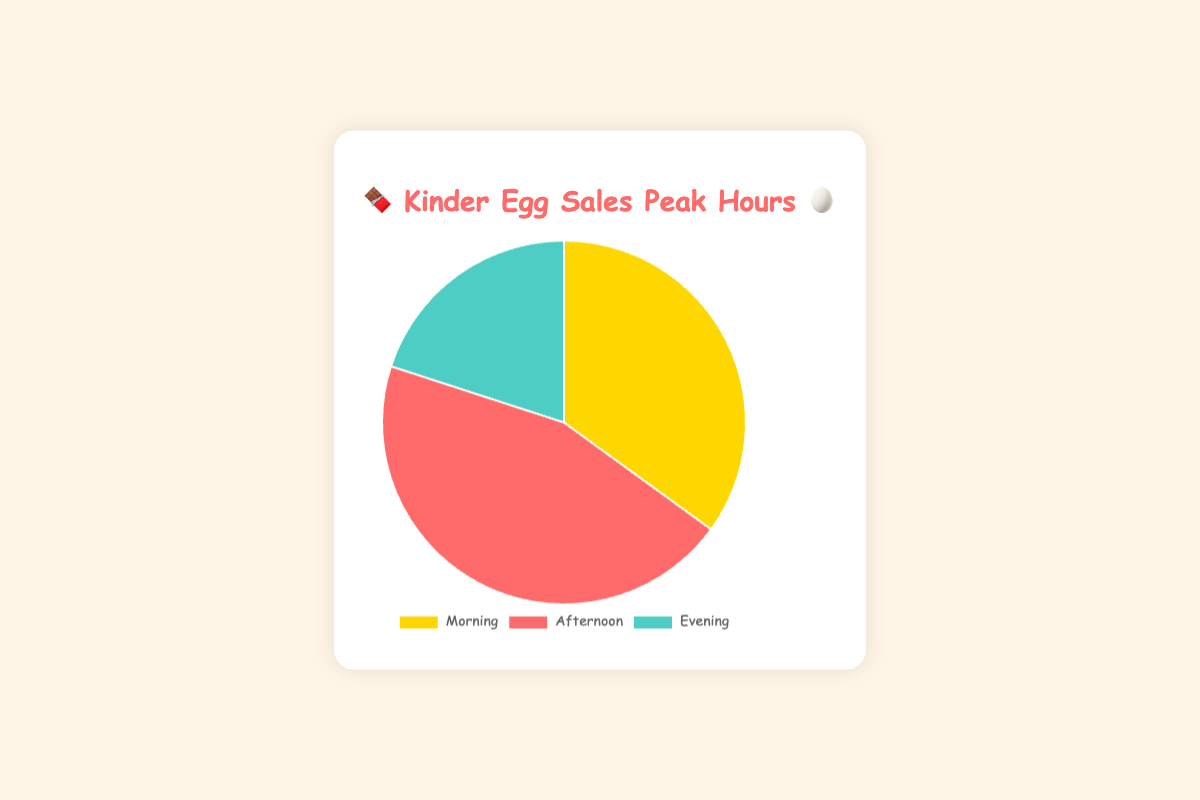what's the peak sales time for Kinder Eggs? The chart shows the sales data divided into three periods: Morning, Afternoon, and Evening. The highest sales percentage is for the Afternoon.
Answer: Afternoon How much higher are the sales in the Afternoon compared to the Evening? The Afternoon sales are 45%, and the Evening sales are 20%. The difference can be calculated as 45% - 20% = 25%.
Answer: 25% What percentage of the sales happen in the Morning? The chart shows that the Morning sales account for 35% of the total sales.
Answer: 35% Which period has the lowest sales percentage? By observing the chart, the period with the smallest segment is the Evening, which has a sales percentage of 20%.
Answer: Evening What are the combined sales percentages for Morning and Evening? Adding the sales percentages for Morning and Evening gives us 35% + 20% = 55%.
Answer: 55% How do Evening sales compare to the Morning sales? The Evening sales (20%) are lower than the Morning sales (35%).
Answer: lower What is the difference between the Morning and Afternoon sales? The Morning sales are 35% and the Afternoon sales are 45%. The difference is 45% - 35% = 10%.
Answer: 10% Which period has the majority of sales? The majority of sales occur during the Afternoon, with the highest percentage of 45%.
Answer: Afternoon What is the average sales percentage for the three periods? The average percentage is calculated by adding the sales percentages and dividing by the number of periods: (35% + 45% + 20%) / 3 = 33.33%.
Answer: 33.33% Describe the colors representing each period on the chart. The Morning is represented by gold, the Afternoon by red, and the Evening by teal.
Answer: gold (Morning), red (Afternoon), teal (Evening) 